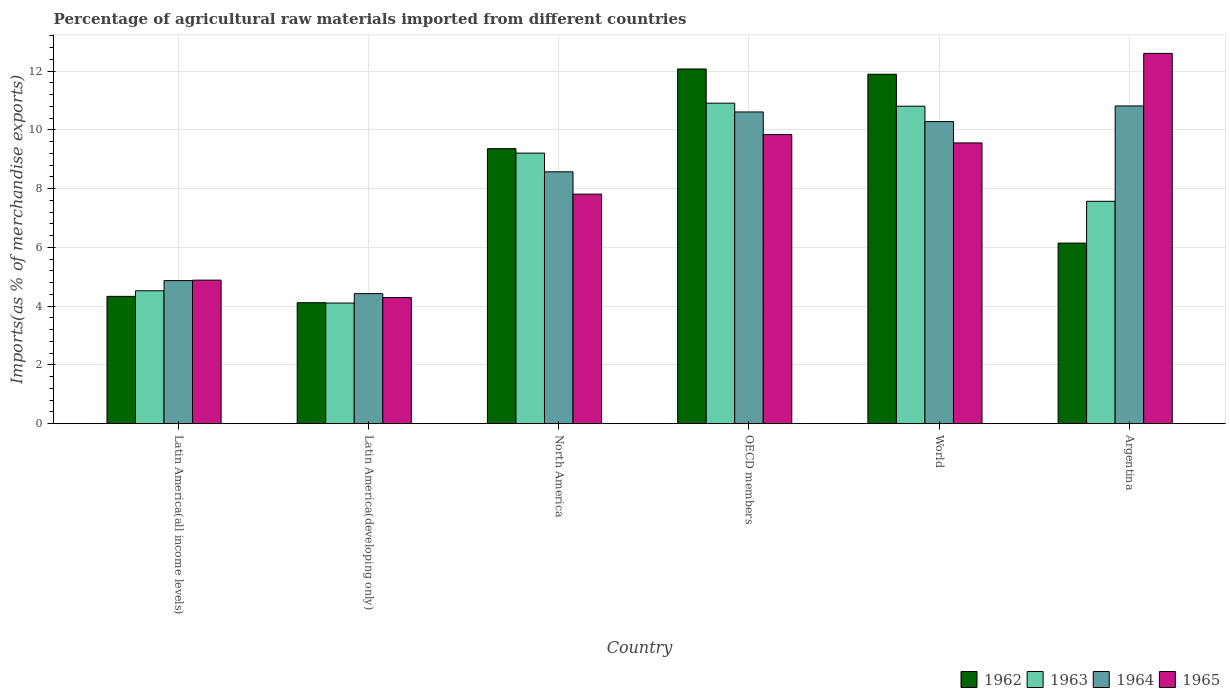Are the number of bars per tick equal to the number of legend labels?
Give a very brief answer. Yes. Are the number of bars on each tick of the X-axis equal?
Your answer should be compact. Yes. How many bars are there on the 5th tick from the left?
Make the answer very short. 4. What is the label of the 1st group of bars from the left?
Give a very brief answer. Latin America(all income levels). What is the percentage of imports to different countries in 1965 in North America?
Your response must be concise. 7.81. Across all countries, what is the maximum percentage of imports to different countries in 1965?
Your answer should be very brief. 12.6. Across all countries, what is the minimum percentage of imports to different countries in 1963?
Your answer should be very brief. 4.11. In which country was the percentage of imports to different countries in 1965 minimum?
Your answer should be compact. Latin America(developing only). What is the total percentage of imports to different countries in 1963 in the graph?
Provide a succinct answer. 47.12. What is the difference between the percentage of imports to different countries in 1965 in Argentina and that in Latin America(all income levels)?
Your answer should be compact. 7.72. What is the difference between the percentage of imports to different countries in 1963 in Latin America(all income levels) and the percentage of imports to different countries in 1962 in North America?
Offer a terse response. -4.84. What is the average percentage of imports to different countries in 1965 per country?
Your answer should be compact. 8.16. What is the difference between the percentage of imports to different countries of/in 1965 and percentage of imports to different countries of/in 1963 in Argentina?
Offer a terse response. 5.03. What is the ratio of the percentage of imports to different countries in 1964 in Latin America(all income levels) to that in World?
Your answer should be very brief. 0.47. Is the percentage of imports to different countries in 1964 in OECD members less than that in World?
Your answer should be very brief. No. Is the difference between the percentage of imports to different countries in 1965 in North America and World greater than the difference between the percentage of imports to different countries in 1963 in North America and World?
Provide a succinct answer. No. What is the difference between the highest and the second highest percentage of imports to different countries in 1962?
Offer a very short reply. -2.53. What is the difference between the highest and the lowest percentage of imports to different countries in 1964?
Keep it short and to the point. 6.39. In how many countries, is the percentage of imports to different countries in 1962 greater than the average percentage of imports to different countries in 1962 taken over all countries?
Make the answer very short. 3. Is the sum of the percentage of imports to different countries in 1962 in Latin America(all income levels) and Latin America(developing only) greater than the maximum percentage of imports to different countries in 1963 across all countries?
Offer a very short reply. No. What does the 1st bar from the left in Latin America(developing only) represents?
Offer a very short reply. 1962. Is it the case that in every country, the sum of the percentage of imports to different countries in 1965 and percentage of imports to different countries in 1963 is greater than the percentage of imports to different countries in 1962?
Offer a terse response. Yes. Are all the bars in the graph horizontal?
Give a very brief answer. No. How many countries are there in the graph?
Ensure brevity in your answer.  6. What is the difference between two consecutive major ticks on the Y-axis?
Offer a terse response. 2. Does the graph contain grids?
Your answer should be very brief. Yes. Where does the legend appear in the graph?
Provide a succinct answer. Bottom right. What is the title of the graph?
Ensure brevity in your answer.  Percentage of agricultural raw materials imported from different countries. What is the label or title of the Y-axis?
Your answer should be compact. Imports(as % of merchandise exports). What is the Imports(as % of merchandise exports) in 1962 in Latin America(all income levels)?
Ensure brevity in your answer.  4.33. What is the Imports(as % of merchandise exports) of 1963 in Latin America(all income levels)?
Your answer should be compact. 4.52. What is the Imports(as % of merchandise exports) of 1964 in Latin America(all income levels)?
Offer a very short reply. 4.87. What is the Imports(as % of merchandise exports) of 1965 in Latin America(all income levels)?
Your answer should be very brief. 4.89. What is the Imports(as % of merchandise exports) in 1962 in Latin America(developing only)?
Your answer should be very brief. 4.12. What is the Imports(as % of merchandise exports) in 1963 in Latin America(developing only)?
Offer a very short reply. 4.11. What is the Imports(as % of merchandise exports) of 1964 in Latin America(developing only)?
Ensure brevity in your answer.  4.43. What is the Imports(as % of merchandise exports) in 1965 in Latin America(developing only)?
Provide a short and direct response. 4.29. What is the Imports(as % of merchandise exports) of 1962 in North America?
Offer a terse response. 9.36. What is the Imports(as % of merchandise exports) of 1963 in North America?
Your answer should be very brief. 9.21. What is the Imports(as % of merchandise exports) in 1964 in North America?
Ensure brevity in your answer.  8.57. What is the Imports(as % of merchandise exports) in 1965 in North America?
Make the answer very short. 7.81. What is the Imports(as % of merchandise exports) in 1962 in OECD members?
Offer a very short reply. 12.07. What is the Imports(as % of merchandise exports) of 1963 in OECD members?
Keep it short and to the point. 10.91. What is the Imports(as % of merchandise exports) in 1964 in OECD members?
Make the answer very short. 10.61. What is the Imports(as % of merchandise exports) in 1965 in OECD members?
Give a very brief answer. 9.84. What is the Imports(as % of merchandise exports) in 1962 in World?
Keep it short and to the point. 11.89. What is the Imports(as % of merchandise exports) in 1963 in World?
Your answer should be very brief. 10.8. What is the Imports(as % of merchandise exports) of 1964 in World?
Ensure brevity in your answer.  10.28. What is the Imports(as % of merchandise exports) of 1965 in World?
Give a very brief answer. 9.56. What is the Imports(as % of merchandise exports) of 1962 in Argentina?
Provide a succinct answer. 6.15. What is the Imports(as % of merchandise exports) of 1963 in Argentina?
Make the answer very short. 7.57. What is the Imports(as % of merchandise exports) of 1964 in Argentina?
Offer a terse response. 10.81. What is the Imports(as % of merchandise exports) in 1965 in Argentina?
Ensure brevity in your answer.  12.6. Across all countries, what is the maximum Imports(as % of merchandise exports) in 1962?
Give a very brief answer. 12.07. Across all countries, what is the maximum Imports(as % of merchandise exports) of 1963?
Your answer should be very brief. 10.91. Across all countries, what is the maximum Imports(as % of merchandise exports) of 1964?
Your answer should be very brief. 10.81. Across all countries, what is the maximum Imports(as % of merchandise exports) in 1965?
Your answer should be very brief. 12.6. Across all countries, what is the minimum Imports(as % of merchandise exports) in 1962?
Provide a succinct answer. 4.12. Across all countries, what is the minimum Imports(as % of merchandise exports) of 1963?
Keep it short and to the point. 4.11. Across all countries, what is the minimum Imports(as % of merchandise exports) in 1964?
Ensure brevity in your answer.  4.43. Across all countries, what is the minimum Imports(as % of merchandise exports) in 1965?
Ensure brevity in your answer.  4.29. What is the total Imports(as % of merchandise exports) of 1962 in the graph?
Ensure brevity in your answer.  47.92. What is the total Imports(as % of merchandise exports) in 1963 in the graph?
Your answer should be very brief. 47.12. What is the total Imports(as % of merchandise exports) in 1964 in the graph?
Make the answer very short. 49.57. What is the total Imports(as % of merchandise exports) in 1965 in the graph?
Keep it short and to the point. 48.99. What is the difference between the Imports(as % of merchandise exports) of 1962 in Latin America(all income levels) and that in Latin America(developing only)?
Offer a very short reply. 0.22. What is the difference between the Imports(as % of merchandise exports) of 1963 in Latin America(all income levels) and that in Latin America(developing only)?
Your answer should be very brief. 0.42. What is the difference between the Imports(as % of merchandise exports) of 1964 in Latin America(all income levels) and that in Latin America(developing only)?
Your response must be concise. 0.44. What is the difference between the Imports(as % of merchandise exports) of 1965 in Latin America(all income levels) and that in Latin America(developing only)?
Your answer should be very brief. 0.59. What is the difference between the Imports(as % of merchandise exports) in 1962 in Latin America(all income levels) and that in North America?
Ensure brevity in your answer.  -5.03. What is the difference between the Imports(as % of merchandise exports) of 1963 in Latin America(all income levels) and that in North America?
Your response must be concise. -4.68. What is the difference between the Imports(as % of merchandise exports) in 1964 in Latin America(all income levels) and that in North America?
Your answer should be very brief. -3.7. What is the difference between the Imports(as % of merchandise exports) of 1965 in Latin America(all income levels) and that in North America?
Give a very brief answer. -2.93. What is the difference between the Imports(as % of merchandise exports) in 1962 in Latin America(all income levels) and that in OECD members?
Offer a very short reply. -7.74. What is the difference between the Imports(as % of merchandise exports) of 1963 in Latin America(all income levels) and that in OECD members?
Ensure brevity in your answer.  -6.38. What is the difference between the Imports(as % of merchandise exports) of 1964 in Latin America(all income levels) and that in OECD members?
Give a very brief answer. -5.74. What is the difference between the Imports(as % of merchandise exports) in 1965 in Latin America(all income levels) and that in OECD members?
Offer a terse response. -4.95. What is the difference between the Imports(as % of merchandise exports) in 1962 in Latin America(all income levels) and that in World?
Offer a very short reply. -7.56. What is the difference between the Imports(as % of merchandise exports) of 1963 in Latin America(all income levels) and that in World?
Keep it short and to the point. -6.28. What is the difference between the Imports(as % of merchandise exports) in 1964 in Latin America(all income levels) and that in World?
Offer a very short reply. -5.41. What is the difference between the Imports(as % of merchandise exports) of 1965 in Latin America(all income levels) and that in World?
Your answer should be very brief. -4.67. What is the difference between the Imports(as % of merchandise exports) in 1962 in Latin America(all income levels) and that in Argentina?
Provide a succinct answer. -1.81. What is the difference between the Imports(as % of merchandise exports) of 1963 in Latin America(all income levels) and that in Argentina?
Offer a very short reply. -3.04. What is the difference between the Imports(as % of merchandise exports) of 1964 in Latin America(all income levels) and that in Argentina?
Make the answer very short. -5.94. What is the difference between the Imports(as % of merchandise exports) of 1965 in Latin America(all income levels) and that in Argentina?
Provide a short and direct response. -7.72. What is the difference between the Imports(as % of merchandise exports) of 1962 in Latin America(developing only) and that in North America?
Offer a terse response. -5.24. What is the difference between the Imports(as % of merchandise exports) in 1963 in Latin America(developing only) and that in North America?
Ensure brevity in your answer.  -5.1. What is the difference between the Imports(as % of merchandise exports) in 1964 in Latin America(developing only) and that in North America?
Provide a succinct answer. -4.15. What is the difference between the Imports(as % of merchandise exports) of 1965 in Latin America(developing only) and that in North America?
Give a very brief answer. -3.52. What is the difference between the Imports(as % of merchandise exports) of 1962 in Latin America(developing only) and that in OECD members?
Your answer should be compact. -7.95. What is the difference between the Imports(as % of merchandise exports) in 1963 in Latin America(developing only) and that in OECD members?
Your answer should be compact. -6.8. What is the difference between the Imports(as % of merchandise exports) of 1964 in Latin America(developing only) and that in OECD members?
Your answer should be very brief. -6.18. What is the difference between the Imports(as % of merchandise exports) of 1965 in Latin America(developing only) and that in OECD members?
Provide a short and direct response. -5.55. What is the difference between the Imports(as % of merchandise exports) of 1962 in Latin America(developing only) and that in World?
Keep it short and to the point. -7.77. What is the difference between the Imports(as % of merchandise exports) in 1963 in Latin America(developing only) and that in World?
Give a very brief answer. -6.7. What is the difference between the Imports(as % of merchandise exports) in 1964 in Latin America(developing only) and that in World?
Your response must be concise. -5.85. What is the difference between the Imports(as % of merchandise exports) in 1965 in Latin America(developing only) and that in World?
Provide a succinct answer. -5.26. What is the difference between the Imports(as % of merchandise exports) in 1962 in Latin America(developing only) and that in Argentina?
Your response must be concise. -2.03. What is the difference between the Imports(as % of merchandise exports) of 1963 in Latin America(developing only) and that in Argentina?
Your response must be concise. -3.46. What is the difference between the Imports(as % of merchandise exports) of 1964 in Latin America(developing only) and that in Argentina?
Offer a very short reply. -6.39. What is the difference between the Imports(as % of merchandise exports) in 1965 in Latin America(developing only) and that in Argentina?
Ensure brevity in your answer.  -8.31. What is the difference between the Imports(as % of merchandise exports) in 1962 in North America and that in OECD members?
Your answer should be very brief. -2.71. What is the difference between the Imports(as % of merchandise exports) of 1963 in North America and that in OECD members?
Ensure brevity in your answer.  -1.7. What is the difference between the Imports(as % of merchandise exports) in 1964 in North America and that in OECD members?
Your response must be concise. -2.04. What is the difference between the Imports(as % of merchandise exports) in 1965 in North America and that in OECD members?
Keep it short and to the point. -2.03. What is the difference between the Imports(as % of merchandise exports) of 1962 in North America and that in World?
Offer a terse response. -2.53. What is the difference between the Imports(as % of merchandise exports) of 1963 in North America and that in World?
Provide a short and direct response. -1.6. What is the difference between the Imports(as % of merchandise exports) in 1964 in North America and that in World?
Keep it short and to the point. -1.71. What is the difference between the Imports(as % of merchandise exports) of 1965 in North America and that in World?
Your answer should be very brief. -1.74. What is the difference between the Imports(as % of merchandise exports) in 1962 in North America and that in Argentina?
Ensure brevity in your answer.  3.21. What is the difference between the Imports(as % of merchandise exports) in 1963 in North America and that in Argentina?
Give a very brief answer. 1.64. What is the difference between the Imports(as % of merchandise exports) of 1964 in North America and that in Argentina?
Offer a very short reply. -2.24. What is the difference between the Imports(as % of merchandise exports) in 1965 in North America and that in Argentina?
Offer a terse response. -4.79. What is the difference between the Imports(as % of merchandise exports) of 1962 in OECD members and that in World?
Keep it short and to the point. 0.18. What is the difference between the Imports(as % of merchandise exports) in 1963 in OECD members and that in World?
Keep it short and to the point. 0.1. What is the difference between the Imports(as % of merchandise exports) of 1964 in OECD members and that in World?
Make the answer very short. 0.33. What is the difference between the Imports(as % of merchandise exports) in 1965 in OECD members and that in World?
Make the answer very short. 0.28. What is the difference between the Imports(as % of merchandise exports) of 1962 in OECD members and that in Argentina?
Provide a short and direct response. 5.92. What is the difference between the Imports(as % of merchandise exports) of 1963 in OECD members and that in Argentina?
Ensure brevity in your answer.  3.34. What is the difference between the Imports(as % of merchandise exports) of 1964 in OECD members and that in Argentina?
Offer a very short reply. -0.2. What is the difference between the Imports(as % of merchandise exports) in 1965 in OECD members and that in Argentina?
Your answer should be compact. -2.76. What is the difference between the Imports(as % of merchandise exports) of 1962 in World and that in Argentina?
Your answer should be very brief. 5.74. What is the difference between the Imports(as % of merchandise exports) of 1963 in World and that in Argentina?
Provide a short and direct response. 3.24. What is the difference between the Imports(as % of merchandise exports) in 1964 in World and that in Argentina?
Provide a succinct answer. -0.53. What is the difference between the Imports(as % of merchandise exports) in 1965 in World and that in Argentina?
Your answer should be compact. -3.05. What is the difference between the Imports(as % of merchandise exports) in 1962 in Latin America(all income levels) and the Imports(as % of merchandise exports) in 1963 in Latin America(developing only)?
Offer a terse response. 0.23. What is the difference between the Imports(as % of merchandise exports) of 1962 in Latin America(all income levels) and the Imports(as % of merchandise exports) of 1964 in Latin America(developing only)?
Your answer should be very brief. -0.09. What is the difference between the Imports(as % of merchandise exports) in 1962 in Latin America(all income levels) and the Imports(as % of merchandise exports) in 1965 in Latin America(developing only)?
Provide a succinct answer. 0.04. What is the difference between the Imports(as % of merchandise exports) of 1963 in Latin America(all income levels) and the Imports(as % of merchandise exports) of 1964 in Latin America(developing only)?
Make the answer very short. 0.1. What is the difference between the Imports(as % of merchandise exports) of 1963 in Latin America(all income levels) and the Imports(as % of merchandise exports) of 1965 in Latin America(developing only)?
Provide a short and direct response. 0.23. What is the difference between the Imports(as % of merchandise exports) of 1964 in Latin America(all income levels) and the Imports(as % of merchandise exports) of 1965 in Latin America(developing only)?
Offer a terse response. 0.58. What is the difference between the Imports(as % of merchandise exports) of 1962 in Latin America(all income levels) and the Imports(as % of merchandise exports) of 1963 in North America?
Provide a succinct answer. -4.87. What is the difference between the Imports(as % of merchandise exports) of 1962 in Latin America(all income levels) and the Imports(as % of merchandise exports) of 1964 in North America?
Offer a very short reply. -4.24. What is the difference between the Imports(as % of merchandise exports) of 1962 in Latin America(all income levels) and the Imports(as % of merchandise exports) of 1965 in North America?
Make the answer very short. -3.48. What is the difference between the Imports(as % of merchandise exports) in 1963 in Latin America(all income levels) and the Imports(as % of merchandise exports) in 1964 in North America?
Offer a very short reply. -4.05. What is the difference between the Imports(as % of merchandise exports) of 1963 in Latin America(all income levels) and the Imports(as % of merchandise exports) of 1965 in North America?
Your answer should be very brief. -3.29. What is the difference between the Imports(as % of merchandise exports) in 1964 in Latin America(all income levels) and the Imports(as % of merchandise exports) in 1965 in North America?
Ensure brevity in your answer.  -2.94. What is the difference between the Imports(as % of merchandise exports) of 1962 in Latin America(all income levels) and the Imports(as % of merchandise exports) of 1963 in OECD members?
Provide a short and direct response. -6.57. What is the difference between the Imports(as % of merchandise exports) of 1962 in Latin America(all income levels) and the Imports(as % of merchandise exports) of 1964 in OECD members?
Make the answer very short. -6.27. What is the difference between the Imports(as % of merchandise exports) in 1962 in Latin America(all income levels) and the Imports(as % of merchandise exports) in 1965 in OECD members?
Ensure brevity in your answer.  -5.51. What is the difference between the Imports(as % of merchandise exports) in 1963 in Latin America(all income levels) and the Imports(as % of merchandise exports) in 1964 in OECD members?
Your answer should be very brief. -6.08. What is the difference between the Imports(as % of merchandise exports) in 1963 in Latin America(all income levels) and the Imports(as % of merchandise exports) in 1965 in OECD members?
Keep it short and to the point. -5.32. What is the difference between the Imports(as % of merchandise exports) in 1964 in Latin America(all income levels) and the Imports(as % of merchandise exports) in 1965 in OECD members?
Ensure brevity in your answer.  -4.97. What is the difference between the Imports(as % of merchandise exports) in 1962 in Latin America(all income levels) and the Imports(as % of merchandise exports) in 1963 in World?
Your response must be concise. -6.47. What is the difference between the Imports(as % of merchandise exports) of 1962 in Latin America(all income levels) and the Imports(as % of merchandise exports) of 1964 in World?
Give a very brief answer. -5.95. What is the difference between the Imports(as % of merchandise exports) of 1962 in Latin America(all income levels) and the Imports(as % of merchandise exports) of 1965 in World?
Provide a short and direct response. -5.22. What is the difference between the Imports(as % of merchandise exports) in 1963 in Latin America(all income levels) and the Imports(as % of merchandise exports) in 1964 in World?
Provide a succinct answer. -5.76. What is the difference between the Imports(as % of merchandise exports) in 1963 in Latin America(all income levels) and the Imports(as % of merchandise exports) in 1965 in World?
Your answer should be very brief. -5.03. What is the difference between the Imports(as % of merchandise exports) in 1964 in Latin America(all income levels) and the Imports(as % of merchandise exports) in 1965 in World?
Give a very brief answer. -4.68. What is the difference between the Imports(as % of merchandise exports) in 1962 in Latin America(all income levels) and the Imports(as % of merchandise exports) in 1963 in Argentina?
Your answer should be compact. -3.23. What is the difference between the Imports(as % of merchandise exports) of 1962 in Latin America(all income levels) and the Imports(as % of merchandise exports) of 1964 in Argentina?
Offer a very short reply. -6.48. What is the difference between the Imports(as % of merchandise exports) in 1962 in Latin America(all income levels) and the Imports(as % of merchandise exports) in 1965 in Argentina?
Provide a succinct answer. -8.27. What is the difference between the Imports(as % of merchandise exports) in 1963 in Latin America(all income levels) and the Imports(as % of merchandise exports) in 1964 in Argentina?
Keep it short and to the point. -6.29. What is the difference between the Imports(as % of merchandise exports) in 1963 in Latin America(all income levels) and the Imports(as % of merchandise exports) in 1965 in Argentina?
Provide a short and direct response. -8.08. What is the difference between the Imports(as % of merchandise exports) of 1964 in Latin America(all income levels) and the Imports(as % of merchandise exports) of 1965 in Argentina?
Provide a succinct answer. -7.73. What is the difference between the Imports(as % of merchandise exports) of 1962 in Latin America(developing only) and the Imports(as % of merchandise exports) of 1963 in North America?
Offer a very short reply. -5.09. What is the difference between the Imports(as % of merchandise exports) of 1962 in Latin America(developing only) and the Imports(as % of merchandise exports) of 1964 in North America?
Give a very brief answer. -4.45. What is the difference between the Imports(as % of merchandise exports) in 1962 in Latin America(developing only) and the Imports(as % of merchandise exports) in 1965 in North America?
Your answer should be very brief. -3.69. What is the difference between the Imports(as % of merchandise exports) of 1963 in Latin America(developing only) and the Imports(as % of merchandise exports) of 1964 in North America?
Give a very brief answer. -4.47. What is the difference between the Imports(as % of merchandise exports) of 1963 in Latin America(developing only) and the Imports(as % of merchandise exports) of 1965 in North America?
Your answer should be compact. -3.71. What is the difference between the Imports(as % of merchandise exports) in 1964 in Latin America(developing only) and the Imports(as % of merchandise exports) in 1965 in North America?
Provide a succinct answer. -3.39. What is the difference between the Imports(as % of merchandise exports) of 1962 in Latin America(developing only) and the Imports(as % of merchandise exports) of 1963 in OECD members?
Your response must be concise. -6.79. What is the difference between the Imports(as % of merchandise exports) of 1962 in Latin America(developing only) and the Imports(as % of merchandise exports) of 1964 in OECD members?
Make the answer very short. -6.49. What is the difference between the Imports(as % of merchandise exports) in 1962 in Latin America(developing only) and the Imports(as % of merchandise exports) in 1965 in OECD members?
Offer a terse response. -5.72. What is the difference between the Imports(as % of merchandise exports) in 1963 in Latin America(developing only) and the Imports(as % of merchandise exports) in 1964 in OECD members?
Your answer should be very brief. -6.5. What is the difference between the Imports(as % of merchandise exports) in 1963 in Latin America(developing only) and the Imports(as % of merchandise exports) in 1965 in OECD members?
Provide a short and direct response. -5.73. What is the difference between the Imports(as % of merchandise exports) in 1964 in Latin America(developing only) and the Imports(as % of merchandise exports) in 1965 in OECD members?
Your response must be concise. -5.41. What is the difference between the Imports(as % of merchandise exports) of 1962 in Latin America(developing only) and the Imports(as % of merchandise exports) of 1963 in World?
Your answer should be very brief. -6.69. What is the difference between the Imports(as % of merchandise exports) in 1962 in Latin America(developing only) and the Imports(as % of merchandise exports) in 1964 in World?
Provide a short and direct response. -6.16. What is the difference between the Imports(as % of merchandise exports) in 1962 in Latin America(developing only) and the Imports(as % of merchandise exports) in 1965 in World?
Ensure brevity in your answer.  -5.44. What is the difference between the Imports(as % of merchandise exports) in 1963 in Latin America(developing only) and the Imports(as % of merchandise exports) in 1964 in World?
Keep it short and to the point. -6.17. What is the difference between the Imports(as % of merchandise exports) in 1963 in Latin America(developing only) and the Imports(as % of merchandise exports) in 1965 in World?
Provide a short and direct response. -5.45. What is the difference between the Imports(as % of merchandise exports) in 1964 in Latin America(developing only) and the Imports(as % of merchandise exports) in 1965 in World?
Provide a succinct answer. -5.13. What is the difference between the Imports(as % of merchandise exports) of 1962 in Latin America(developing only) and the Imports(as % of merchandise exports) of 1963 in Argentina?
Provide a succinct answer. -3.45. What is the difference between the Imports(as % of merchandise exports) of 1962 in Latin America(developing only) and the Imports(as % of merchandise exports) of 1964 in Argentina?
Your answer should be very brief. -6.69. What is the difference between the Imports(as % of merchandise exports) in 1962 in Latin America(developing only) and the Imports(as % of merchandise exports) in 1965 in Argentina?
Provide a succinct answer. -8.48. What is the difference between the Imports(as % of merchandise exports) in 1963 in Latin America(developing only) and the Imports(as % of merchandise exports) in 1964 in Argentina?
Offer a terse response. -6.71. What is the difference between the Imports(as % of merchandise exports) of 1963 in Latin America(developing only) and the Imports(as % of merchandise exports) of 1965 in Argentina?
Provide a succinct answer. -8.49. What is the difference between the Imports(as % of merchandise exports) in 1964 in Latin America(developing only) and the Imports(as % of merchandise exports) in 1965 in Argentina?
Offer a terse response. -8.17. What is the difference between the Imports(as % of merchandise exports) in 1962 in North America and the Imports(as % of merchandise exports) in 1963 in OECD members?
Give a very brief answer. -1.55. What is the difference between the Imports(as % of merchandise exports) in 1962 in North America and the Imports(as % of merchandise exports) in 1964 in OECD members?
Make the answer very short. -1.25. What is the difference between the Imports(as % of merchandise exports) of 1962 in North America and the Imports(as % of merchandise exports) of 1965 in OECD members?
Your answer should be very brief. -0.48. What is the difference between the Imports(as % of merchandise exports) in 1963 in North America and the Imports(as % of merchandise exports) in 1964 in OECD members?
Provide a short and direct response. -1.4. What is the difference between the Imports(as % of merchandise exports) of 1963 in North America and the Imports(as % of merchandise exports) of 1965 in OECD members?
Your answer should be very brief. -0.63. What is the difference between the Imports(as % of merchandise exports) in 1964 in North America and the Imports(as % of merchandise exports) in 1965 in OECD members?
Make the answer very short. -1.27. What is the difference between the Imports(as % of merchandise exports) in 1962 in North America and the Imports(as % of merchandise exports) in 1963 in World?
Keep it short and to the point. -1.44. What is the difference between the Imports(as % of merchandise exports) of 1962 in North America and the Imports(as % of merchandise exports) of 1964 in World?
Give a very brief answer. -0.92. What is the difference between the Imports(as % of merchandise exports) in 1962 in North America and the Imports(as % of merchandise exports) in 1965 in World?
Your response must be concise. -0.2. What is the difference between the Imports(as % of merchandise exports) in 1963 in North America and the Imports(as % of merchandise exports) in 1964 in World?
Provide a short and direct response. -1.07. What is the difference between the Imports(as % of merchandise exports) in 1963 in North America and the Imports(as % of merchandise exports) in 1965 in World?
Provide a succinct answer. -0.35. What is the difference between the Imports(as % of merchandise exports) of 1964 in North America and the Imports(as % of merchandise exports) of 1965 in World?
Offer a very short reply. -0.98. What is the difference between the Imports(as % of merchandise exports) in 1962 in North America and the Imports(as % of merchandise exports) in 1963 in Argentina?
Offer a very short reply. 1.79. What is the difference between the Imports(as % of merchandise exports) of 1962 in North America and the Imports(as % of merchandise exports) of 1964 in Argentina?
Offer a terse response. -1.45. What is the difference between the Imports(as % of merchandise exports) of 1962 in North America and the Imports(as % of merchandise exports) of 1965 in Argentina?
Your answer should be very brief. -3.24. What is the difference between the Imports(as % of merchandise exports) in 1963 in North America and the Imports(as % of merchandise exports) in 1964 in Argentina?
Offer a terse response. -1.61. What is the difference between the Imports(as % of merchandise exports) in 1963 in North America and the Imports(as % of merchandise exports) in 1965 in Argentina?
Your answer should be compact. -3.39. What is the difference between the Imports(as % of merchandise exports) of 1964 in North America and the Imports(as % of merchandise exports) of 1965 in Argentina?
Your response must be concise. -4.03. What is the difference between the Imports(as % of merchandise exports) in 1962 in OECD members and the Imports(as % of merchandise exports) in 1963 in World?
Keep it short and to the point. 1.27. What is the difference between the Imports(as % of merchandise exports) of 1962 in OECD members and the Imports(as % of merchandise exports) of 1964 in World?
Your response must be concise. 1.79. What is the difference between the Imports(as % of merchandise exports) of 1962 in OECD members and the Imports(as % of merchandise exports) of 1965 in World?
Offer a terse response. 2.52. What is the difference between the Imports(as % of merchandise exports) in 1963 in OECD members and the Imports(as % of merchandise exports) in 1964 in World?
Provide a succinct answer. 0.63. What is the difference between the Imports(as % of merchandise exports) in 1963 in OECD members and the Imports(as % of merchandise exports) in 1965 in World?
Your response must be concise. 1.35. What is the difference between the Imports(as % of merchandise exports) in 1964 in OECD members and the Imports(as % of merchandise exports) in 1965 in World?
Your answer should be compact. 1.05. What is the difference between the Imports(as % of merchandise exports) of 1962 in OECD members and the Imports(as % of merchandise exports) of 1963 in Argentina?
Give a very brief answer. 4.5. What is the difference between the Imports(as % of merchandise exports) in 1962 in OECD members and the Imports(as % of merchandise exports) in 1964 in Argentina?
Provide a succinct answer. 1.26. What is the difference between the Imports(as % of merchandise exports) of 1962 in OECD members and the Imports(as % of merchandise exports) of 1965 in Argentina?
Your answer should be very brief. -0.53. What is the difference between the Imports(as % of merchandise exports) in 1963 in OECD members and the Imports(as % of merchandise exports) in 1964 in Argentina?
Provide a short and direct response. 0.09. What is the difference between the Imports(as % of merchandise exports) in 1963 in OECD members and the Imports(as % of merchandise exports) in 1965 in Argentina?
Offer a very short reply. -1.69. What is the difference between the Imports(as % of merchandise exports) in 1964 in OECD members and the Imports(as % of merchandise exports) in 1965 in Argentina?
Provide a short and direct response. -1.99. What is the difference between the Imports(as % of merchandise exports) in 1962 in World and the Imports(as % of merchandise exports) in 1963 in Argentina?
Provide a succinct answer. 4.32. What is the difference between the Imports(as % of merchandise exports) in 1962 in World and the Imports(as % of merchandise exports) in 1964 in Argentina?
Offer a very short reply. 1.08. What is the difference between the Imports(as % of merchandise exports) of 1962 in World and the Imports(as % of merchandise exports) of 1965 in Argentina?
Your answer should be very brief. -0.71. What is the difference between the Imports(as % of merchandise exports) in 1963 in World and the Imports(as % of merchandise exports) in 1964 in Argentina?
Your answer should be very brief. -0.01. What is the difference between the Imports(as % of merchandise exports) in 1963 in World and the Imports(as % of merchandise exports) in 1965 in Argentina?
Provide a succinct answer. -1.8. What is the difference between the Imports(as % of merchandise exports) of 1964 in World and the Imports(as % of merchandise exports) of 1965 in Argentina?
Provide a short and direct response. -2.32. What is the average Imports(as % of merchandise exports) in 1962 per country?
Offer a very short reply. 7.99. What is the average Imports(as % of merchandise exports) in 1963 per country?
Your answer should be very brief. 7.85. What is the average Imports(as % of merchandise exports) of 1964 per country?
Your answer should be compact. 8.26. What is the average Imports(as % of merchandise exports) in 1965 per country?
Provide a succinct answer. 8.16. What is the difference between the Imports(as % of merchandise exports) in 1962 and Imports(as % of merchandise exports) in 1963 in Latin America(all income levels)?
Provide a succinct answer. -0.19. What is the difference between the Imports(as % of merchandise exports) in 1962 and Imports(as % of merchandise exports) in 1964 in Latin America(all income levels)?
Provide a short and direct response. -0.54. What is the difference between the Imports(as % of merchandise exports) in 1962 and Imports(as % of merchandise exports) in 1965 in Latin America(all income levels)?
Ensure brevity in your answer.  -0.55. What is the difference between the Imports(as % of merchandise exports) of 1963 and Imports(as % of merchandise exports) of 1964 in Latin America(all income levels)?
Offer a very short reply. -0.35. What is the difference between the Imports(as % of merchandise exports) of 1963 and Imports(as % of merchandise exports) of 1965 in Latin America(all income levels)?
Provide a succinct answer. -0.36. What is the difference between the Imports(as % of merchandise exports) in 1964 and Imports(as % of merchandise exports) in 1965 in Latin America(all income levels)?
Provide a short and direct response. -0.02. What is the difference between the Imports(as % of merchandise exports) in 1962 and Imports(as % of merchandise exports) in 1963 in Latin America(developing only)?
Your answer should be compact. 0.01. What is the difference between the Imports(as % of merchandise exports) in 1962 and Imports(as % of merchandise exports) in 1964 in Latin America(developing only)?
Your response must be concise. -0.31. What is the difference between the Imports(as % of merchandise exports) of 1962 and Imports(as % of merchandise exports) of 1965 in Latin America(developing only)?
Give a very brief answer. -0.17. What is the difference between the Imports(as % of merchandise exports) of 1963 and Imports(as % of merchandise exports) of 1964 in Latin America(developing only)?
Give a very brief answer. -0.32. What is the difference between the Imports(as % of merchandise exports) in 1963 and Imports(as % of merchandise exports) in 1965 in Latin America(developing only)?
Ensure brevity in your answer.  -0.19. What is the difference between the Imports(as % of merchandise exports) in 1964 and Imports(as % of merchandise exports) in 1965 in Latin America(developing only)?
Offer a very short reply. 0.13. What is the difference between the Imports(as % of merchandise exports) of 1962 and Imports(as % of merchandise exports) of 1963 in North America?
Provide a short and direct response. 0.15. What is the difference between the Imports(as % of merchandise exports) of 1962 and Imports(as % of merchandise exports) of 1964 in North America?
Your answer should be compact. 0.79. What is the difference between the Imports(as % of merchandise exports) in 1962 and Imports(as % of merchandise exports) in 1965 in North America?
Provide a succinct answer. 1.55. What is the difference between the Imports(as % of merchandise exports) in 1963 and Imports(as % of merchandise exports) in 1964 in North America?
Your answer should be compact. 0.64. What is the difference between the Imports(as % of merchandise exports) in 1963 and Imports(as % of merchandise exports) in 1965 in North America?
Keep it short and to the point. 1.39. What is the difference between the Imports(as % of merchandise exports) of 1964 and Imports(as % of merchandise exports) of 1965 in North America?
Offer a terse response. 0.76. What is the difference between the Imports(as % of merchandise exports) of 1962 and Imports(as % of merchandise exports) of 1963 in OECD members?
Provide a succinct answer. 1.16. What is the difference between the Imports(as % of merchandise exports) of 1962 and Imports(as % of merchandise exports) of 1964 in OECD members?
Offer a very short reply. 1.46. What is the difference between the Imports(as % of merchandise exports) of 1962 and Imports(as % of merchandise exports) of 1965 in OECD members?
Your answer should be very brief. 2.23. What is the difference between the Imports(as % of merchandise exports) in 1963 and Imports(as % of merchandise exports) in 1964 in OECD members?
Offer a very short reply. 0.3. What is the difference between the Imports(as % of merchandise exports) in 1963 and Imports(as % of merchandise exports) in 1965 in OECD members?
Your response must be concise. 1.07. What is the difference between the Imports(as % of merchandise exports) of 1964 and Imports(as % of merchandise exports) of 1965 in OECD members?
Provide a short and direct response. 0.77. What is the difference between the Imports(as % of merchandise exports) in 1962 and Imports(as % of merchandise exports) in 1963 in World?
Give a very brief answer. 1.09. What is the difference between the Imports(as % of merchandise exports) of 1962 and Imports(as % of merchandise exports) of 1964 in World?
Provide a succinct answer. 1.61. What is the difference between the Imports(as % of merchandise exports) in 1962 and Imports(as % of merchandise exports) in 1965 in World?
Your answer should be compact. 2.34. What is the difference between the Imports(as % of merchandise exports) in 1963 and Imports(as % of merchandise exports) in 1964 in World?
Provide a short and direct response. 0.52. What is the difference between the Imports(as % of merchandise exports) of 1963 and Imports(as % of merchandise exports) of 1965 in World?
Your answer should be compact. 1.25. What is the difference between the Imports(as % of merchandise exports) of 1964 and Imports(as % of merchandise exports) of 1965 in World?
Your answer should be compact. 0.73. What is the difference between the Imports(as % of merchandise exports) of 1962 and Imports(as % of merchandise exports) of 1963 in Argentina?
Provide a short and direct response. -1.42. What is the difference between the Imports(as % of merchandise exports) in 1962 and Imports(as % of merchandise exports) in 1964 in Argentina?
Provide a succinct answer. -4.67. What is the difference between the Imports(as % of merchandise exports) of 1962 and Imports(as % of merchandise exports) of 1965 in Argentina?
Your response must be concise. -6.45. What is the difference between the Imports(as % of merchandise exports) of 1963 and Imports(as % of merchandise exports) of 1964 in Argentina?
Provide a short and direct response. -3.24. What is the difference between the Imports(as % of merchandise exports) of 1963 and Imports(as % of merchandise exports) of 1965 in Argentina?
Your response must be concise. -5.03. What is the difference between the Imports(as % of merchandise exports) in 1964 and Imports(as % of merchandise exports) in 1965 in Argentina?
Keep it short and to the point. -1.79. What is the ratio of the Imports(as % of merchandise exports) in 1962 in Latin America(all income levels) to that in Latin America(developing only)?
Your response must be concise. 1.05. What is the ratio of the Imports(as % of merchandise exports) in 1963 in Latin America(all income levels) to that in Latin America(developing only)?
Give a very brief answer. 1.1. What is the ratio of the Imports(as % of merchandise exports) of 1964 in Latin America(all income levels) to that in Latin America(developing only)?
Keep it short and to the point. 1.1. What is the ratio of the Imports(as % of merchandise exports) in 1965 in Latin America(all income levels) to that in Latin America(developing only)?
Your response must be concise. 1.14. What is the ratio of the Imports(as % of merchandise exports) of 1962 in Latin America(all income levels) to that in North America?
Provide a short and direct response. 0.46. What is the ratio of the Imports(as % of merchandise exports) of 1963 in Latin America(all income levels) to that in North America?
Offer a very short reply. 0.49. What is the ratio of the Imports(as % of merchandise exports) in 1964 in Latin America(all income levels) to that in North America?
Provide a succinct answer. 0.57. What is the ratio of the Imports(as % of merchandise exports) in 1965 in Latin America(all income levels) to that in North America?
Offer a terse response. 0.63. What is the ratio of the Imports(as % of merchandise exports) of 1962 in Latin America(all income levels) to that in OECD members?
Your answer should be very brief. 0.36. What is the ratio of the Imports(as % of merchandise exports) of 1963 in Latin America(all income levels) to that in OECD members?
Provide a short and direct response. 0.41. What is the ratio of the Imports(as % of merchandise exports) of 1964 in Latin America(all income levels) to that in OECD members?
Your answer should be very brief. 0.46. What is the ratio of the Imports(as % of merchandise exports) of 1965 in Latin America(all income levels) to that in OECD members?
Ensure brevity in your answer.  0.5. What is the ratio of the Imports(as % of merchandise exports) of 1962 in Latin America(all income levels) to that in World?
Your response must be concise. 0.36. What is the ratio of the Imports(as % of merchandise exports) of 1963 in Latin America(all income levels) to that in World?
Give a very brief answer. 0.42. What is the ratio of the Imports(as % of merchandise exports) of 1964 in Latin America(all income levels) to that in World?
Keep it short and to the point. 0.47. What is the ratio of the Imports(as % of merchandise exports) in 1965 in Latin America(all income levels) to that in World?
Give a very brief answer. 0.51. What is the ratio of the Imports(as % of merchandise exports) in 1962 in Latin America(all income levels) to that in Argentina?
Provide a succinct answer. 0.71. What is the ratio of the Imports(as % of merchandise exports) of 1963 in Latin America(all income levels) to that in Argentina?
Provide a succinct answer. 0.6. What is the ratio of the Imports(as % of merchandise exports) in 1964 in Latin America(all income levels) to that in Argentina?
Ensure brevity in your answer.  0.45. What is the ratio of the Imports(as % of merchandise exports) in 1965 in Latin America(all income levels) to that in Argentina?
Keep it short and to the point. 0.39. What is the ratio of the Imports(as % of merchandise exports) of 1962 in Latin America(developing only) to that in North America?
Keep it short and to the point. 0.44. What is the ratio of the Imports(as % of merchandise exports) of 1963 in Latin America(developing only) to that in North America?
Your response must be concise. 0.45. What is the ratio of the Imports(as % of merchandise exports) of 1964 in Latin America(developing only) to that in North America?
Offer a terse response. 0.52. What is the ratio of the Imports(as % of merchandise exports) of 1965 in Latin America(developing only) to that in North America?
Ensure brevity in your answer.  0.55. What is the ratio of the Imports(as % of merchandise exports) in 1962 in Latin America(developing only) to that in OECD members?
Your answer should be very brief. 0.34. What is the ratio of the Imports(as % of merchandise exports) of 1963 in Latin America(developing only) to that in OECD members?
Provide a succinct answer. 0.38. What is the ratio of the Imports(as % of merchandise exports) in 1964 in Latin America(developing only) to that in OECD members?
Provide a succinct answer. 0.42. What is the ratio of the Imports(as % of merchandise exports) of 1965 in Latin America(developing only) to that in OECD members?
Keep it short and to the point. 0.44. What is the ratio of the Imports(as % of merchandise exports) in 1962 in Latin America(developing only) to that in World?
Your response must be concise. 0.35. What is the ratio of the Imports(as % of merchandise exports) in 1963 in Latin America(developing only) to that in World?
Provide a succinct answer. 0.38. What is the ratio of the Imports(as % of merchandise exports) of 1964 in Latin America(developing only) to that in World?
Keep it short and to the point. 0.43. What is the ratio of the Imports(as % of merchandise exports) of 1965 in Latin America(developing only) to that in World?
Ensure brevity in your answer.  0.45. What is the ratio of the Imports(as % of merchandise exports) in 1962 in Latin America(developing only) to that in Argentina?
Offer a very short reply. 0.67. What is the ratio of the Imports(as % of merchandise exports) of 1963 in Latin America(developing only) to that in Argentina?
Offer a very short reply. 0.54. What is the ratio of the Imports(as % of merchandise exports) of 1964 in Latin America(developing only) to that in Argentina?
Ensure brevity in your answer.  0.41. What is the ratio of the Imports(as % of merchandise exports) of 1965 in Latin America(developing only) to that in Argentina?
Offer a terse response. 0.34. What is the ratio of the Imports(as % of merchandise exports) of 1962 in North America to that in OECD members?
Offer a terse response. 0.78. What is the ratio of the Imports(as % of merchandise exports) of 1963 in North America to that in OECD members?
Your response must be concise. 0.84. What is the ratio of the Imports(as % of merchandise exports) in 1964 in North America to that in OECD members?
Ensure brevity in your answer.  0.81. What is the ratio of the Imports(as % of merchandise exports) of 1965 in North America to that in OECD members?
Make the answer very short. 0.79. What is the ratio of the Imports(as % of merchandise exports) in 1962 in North America to that in World?
Give a very brief answer. 0.79. What is the ratio of the Imports(as % of merchandise exports) in 1963 in North America to that in World?
Your answer should be very brief. 0.85. What is the ratio of the Imports(as % of merchandise exports) in 1964 in North America to that in World?
Offer a terse response. 0.83. What is the ratio of the Imports(as % of merchandise exports) in 1965 in North America to that in World?
Offer a very short reply. 0.82. What is the ratio of the Imports(as % of merchandise exports) of 1962 in North America to that in Argentina?
Offer a very short reply. 1.52. What is the ratio of the Imports(as % of merchandise exports) of 1963 in North America to that in Argentina?
Ensure brevity in your answer.  1.22. What is the ratio of the Imports(as % of merchandise exports) of 1964 in North America to that in Argentina?
Your response must be concise. 0.79. What is the ratio of the Imports(as % of merchandise exports) of 1965 in North America to that in Argentina?
Offer a very short reply. 0.62. What is the ratio of the Imports(as % of merchandise exports) of 1962 in OECD members to that in World?
Provide a succinct answer. 1.02. What is the ratio of the Imports(as % of merchandise exports) in 1963 in OECD members to that in World?
Your answer should be very brief. 1.01. What is the ratio of the Imports(as % of merchandise exports) of 1964 in OECD members to that in World?
Offer a very short reply. 1.03. What is the ratio of the Imports(as % of merchandise exports) of 1965 in OECD members to that in World?
Make the answer very short. 1.03. What is the ratio of the Imports(as % of merchandise exports) in 1962 in OECD members to that in Argentina?
Keep it short and to the point. 1.96. What is the ratio of the Imports(as % of merchandise exports) in 1963 in OECD members to that in Argentina?
Your answer should be very brief. 1.44. What is the ratio of the Imports(as % of merchandise exports) in 1964 in OECD members to that in Argentina?
Your response must be concise. 0.98. What is the ratio of the Imports(as % of merchandise exports) in 1965 in OECD members to that in Argentina?
Your answer should be compact. 0.78. What is the ratio of the Imports(as % of merchandise exports) of 1962 in World to that in Argentina?
Your response must be concise. 1.93. What is the ratio of the Imports(as % of merchandise exports) of 1963 in World to that in Argentina?
Offer a terse response. 1.43. What is the ratio of the Imports(as % of merchandise exports) in 1964 in World to that in Argentina?
Offer a terse response. 0.95. What is the ratio of the Imports(as % of merchandise exports) in 1965 in World to that in Argentina?
Offer a terse response. 0.76. What is the difference between the highest and the second highest Imports(as % of merchandise exports) in 1962?
Offer a terse response. 0.18. What is the difference between the highest and the second highest Imports(as % of merchandise exports) of 1963?
Your answer should be compact. 0.1. What is the difference between the highest and the second highest Imports(as % of merchandise exports) of 1964?
Provide a succinct answer. 0.2. What is the difference between the highest and the second highest Imports(as % of merchandise exports) of 1965?
Ensure brevity in your answer.  2.76. What is the difference between the highest and the lowest Imports(as % of merchandise exports) of 1962?
Your response must be concise. 7.95. What is the difference between the highest and the lowest Imports(as % of merchandise exports) in 1963?
Offer a very short reply. 6.8. What is the difference between the highest and the lowest Imports(as % of merchandise exports) in 1964?
Keep it short and to the point. 6.39. What is the difference between the highest and the lowest Imports(as % of merchandise exports) of 1965?
Keep it short and to the point. 8.31. 